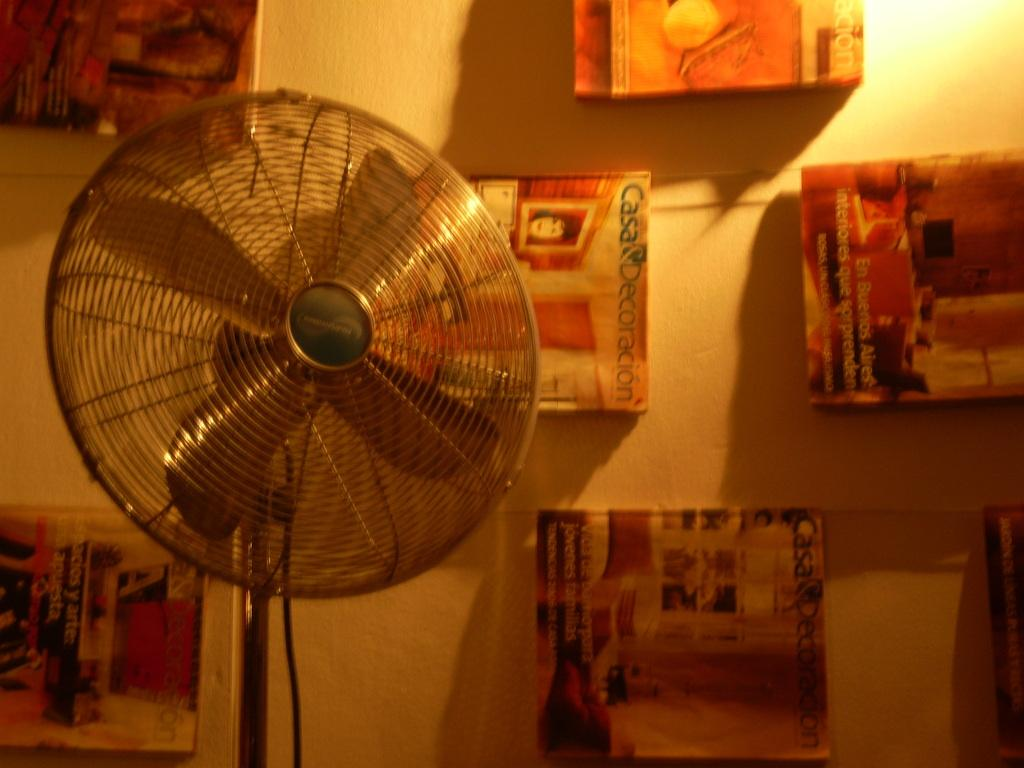<image>
Create a compact narrative representing the image presented. Magazines are hanging behind a fan and one is titled Casa and Decoracion. 